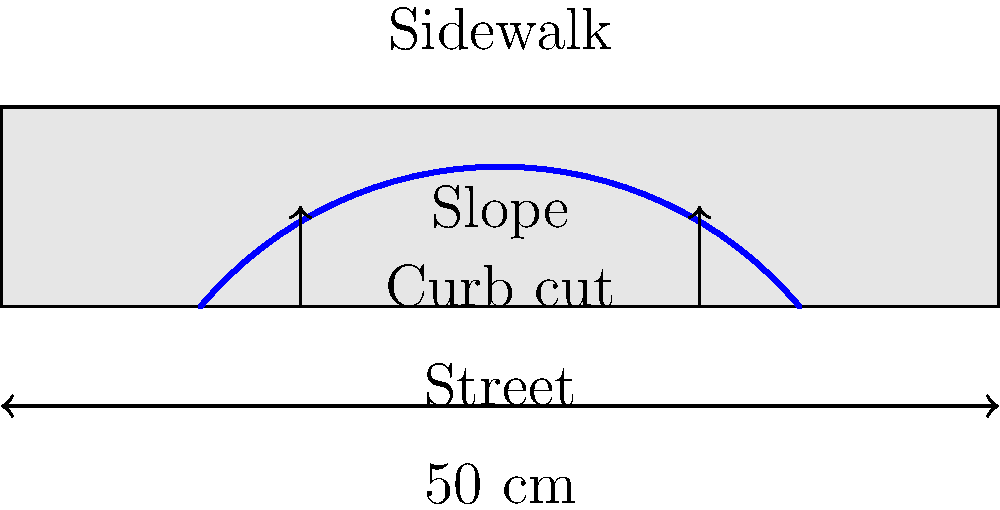Based on the cross-sectional view of a curb cut design shown above, which aspect of this design is most crucial for ensuring accessibility and safety for wheelchair users, and why? To answer this question, we need to consider the key elements of curb cut design that affect wheelchair users:

1. Slope: The curb cut's slope is the most critical aspect for wheelchair accessibility and safety. In the diagram, we can see a gradual slope from the street level to the sidewalk level.

2. Width: The curb cut spans most of the curb width (40 cm out of 50 cm), allowing enough space for a wheelchair to navigate.

3. Smooth transition: The curve of the cut provides a smooth transition from street to sidewalk, without abrupt changes in elevation.

4. Lack of lips or edges: There are no visible lips or edges at the bottom of the curb cut, which could pose hazards to wheelchair users.

Among these elements, the slope is the most crucial because:

a) It determines the ease with which a wheelchair user can ascend or descend the curb cut.
b) A slope that is too steep can be dangerous, potentially causing wheelchairs to tip backward or accelerate too quickly when descending.
c) The Americans with Disabilities Act (ADA) specifically regulates curb cut slopes, requiring a maximum slope of 1:12 (8.33%) for the main slope and 1:10 (10%) for side flares.

The slope affects both the accessibility (ability to use the curb cut) and safety (risk of accidents while using it) for wheelchair users, making it the most critical aspect of the design.
Answer: The slope, as it directly impacts both accessibility and safety for wheelchair users. 